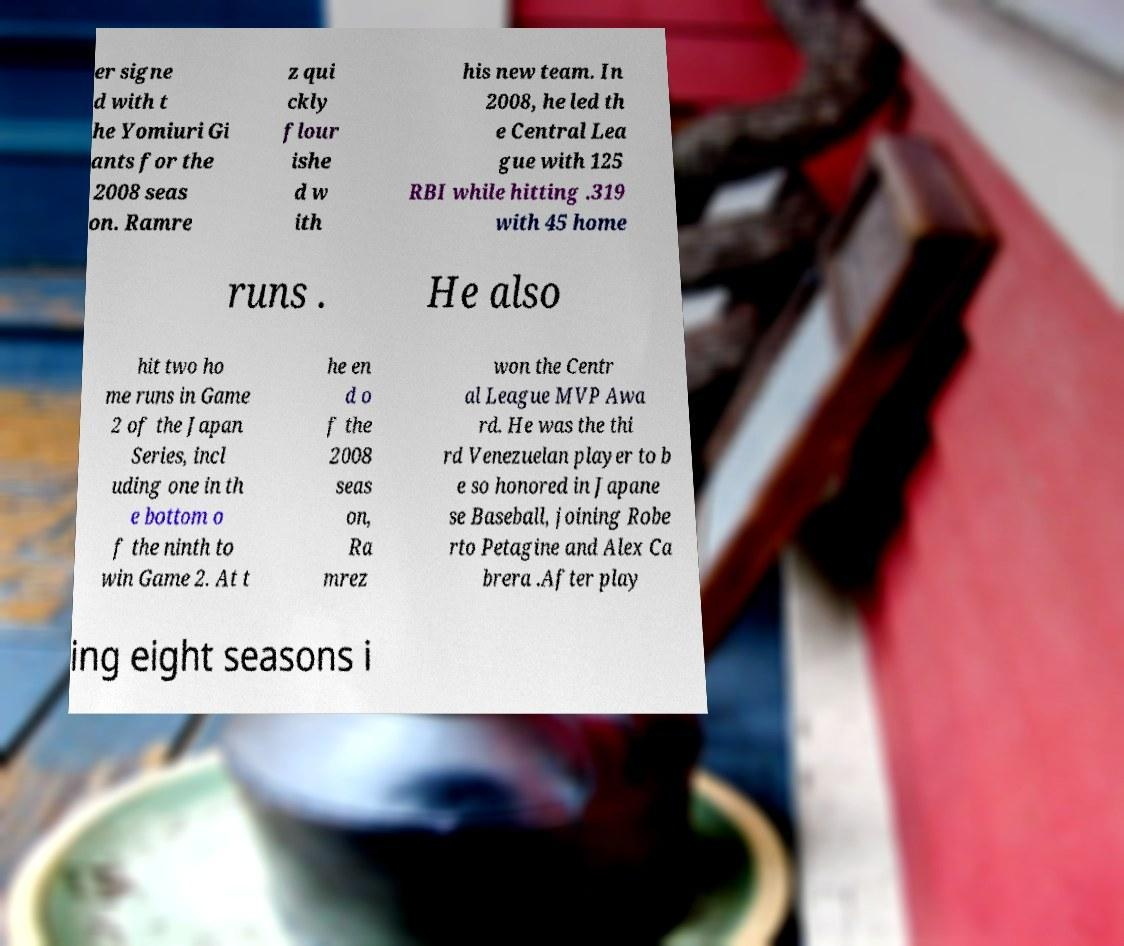Can you read and provide the text displayed in the image?This photo seems to have some interesting text. Can you extract and type it out for me? er signe d with t he Yomiuri Gi ants for the 2008 seas on. Ramre z qui ckly flour ishe d w ith his new team. In 2008, he led th e Central Lea gue with 125 RBI while hitting .319 with 45 home runs . He also hit two ho me runs in Game 2 of the Japan Series, incl uding one in th e bottom o f the ninth to win Game 2. At t he en d o f the 2008 seas on, Ra mrez won the Centr al League MVP Awa rd. He was the thi rd Venezuelan player to b e so honored in Japane se Baseball, joining Robe rto Petagine and Alex Ca brera .After play ing eight seasons i 